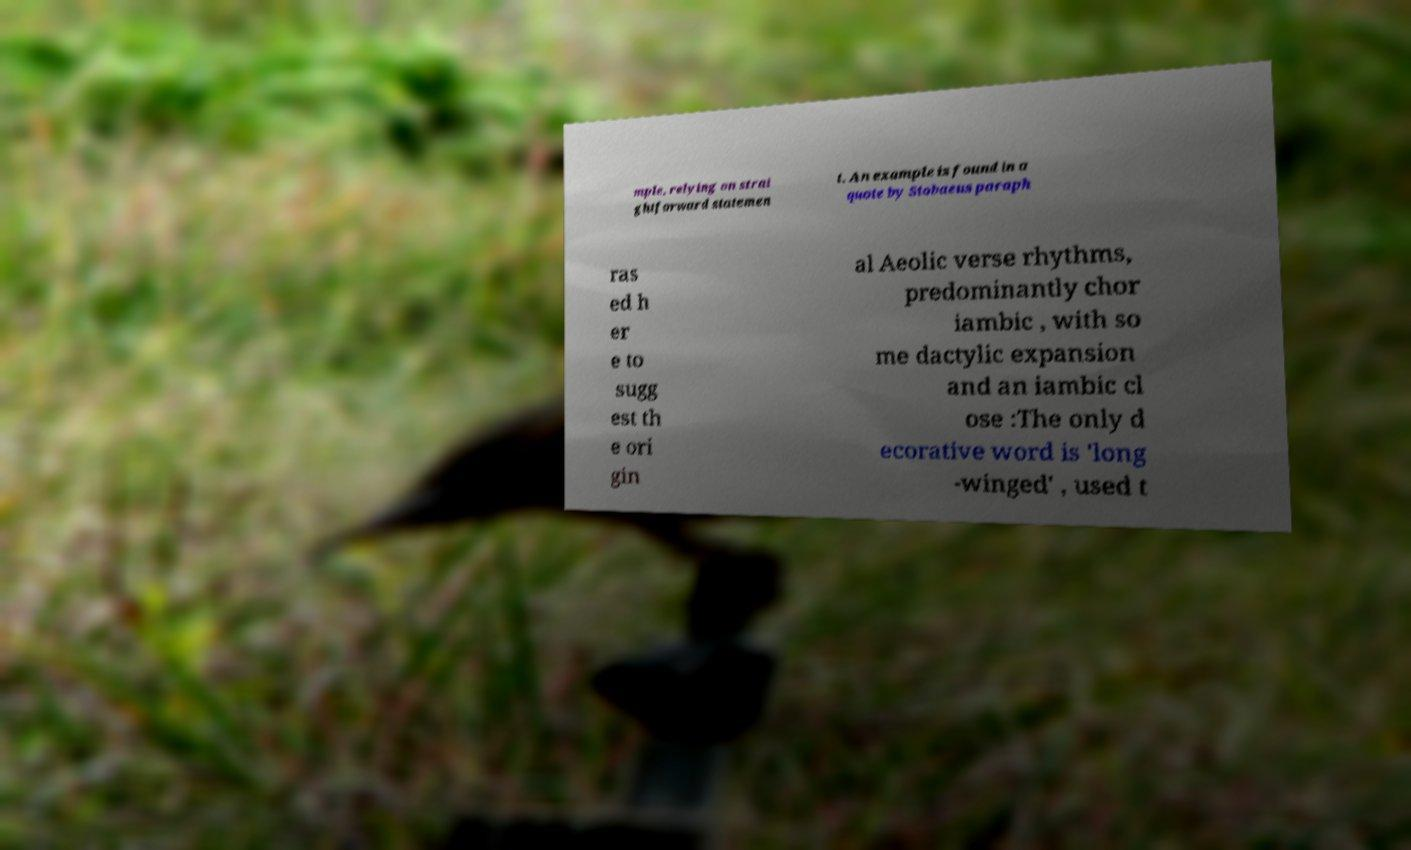For documentation purposes, I need the text within this image transcribed. Could you provide that? mple, relying on strai ghtforward statemen t. An example is found in a quote by Stobaeus paraph ras ed h er e to sugg est th e ori gin al Aeolic verse rhythms, predominantly chor iambic , with so me dactylic expansion and an iambic cl ose :The only d ecorative word is 'long -winged' , used t 